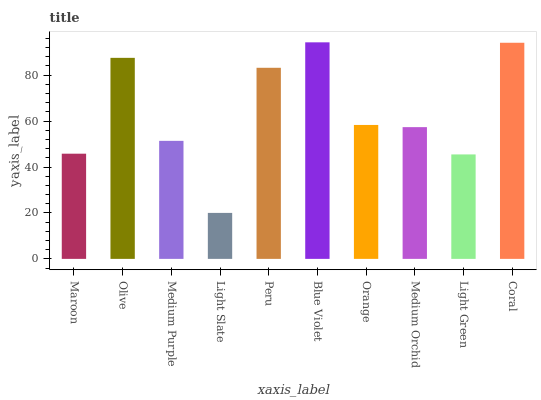Is Olive the minimum?
Answer yes or no. No. Is Olive the maximum?
Answer yes or no. No. Is Olive greater than Maroon?
Answer yes or no. Yes. Is Maroon less than Olive?
Answer yes or no. Yes. Is Maroon greater than Olive?
Answer yes or no. No. Is Olive less than Maroon?
Answer yes or no. No. Is Orange the high median?
Answer yes or no. Yes. Is Medium Orchid the low median?
Answer yes or no. Yes. Is Medium Purple the high median?
Answer yes or no. No. Is Orange the low median?
Answer yes or no. No. 